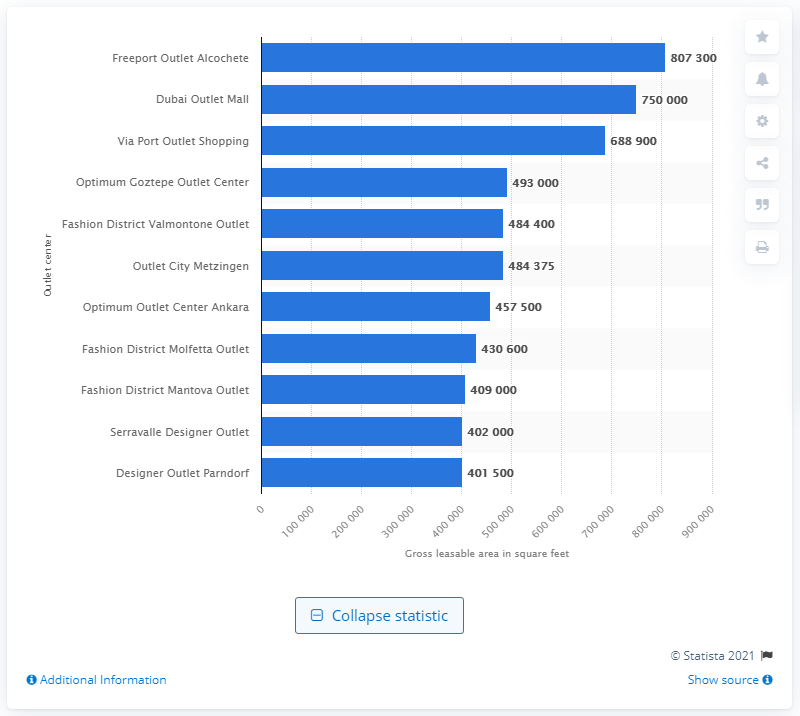Point out several critical features in this image. The Freeport Outlet Alcochete was the largest outlet center in Europe and the Middle East in 2011. 